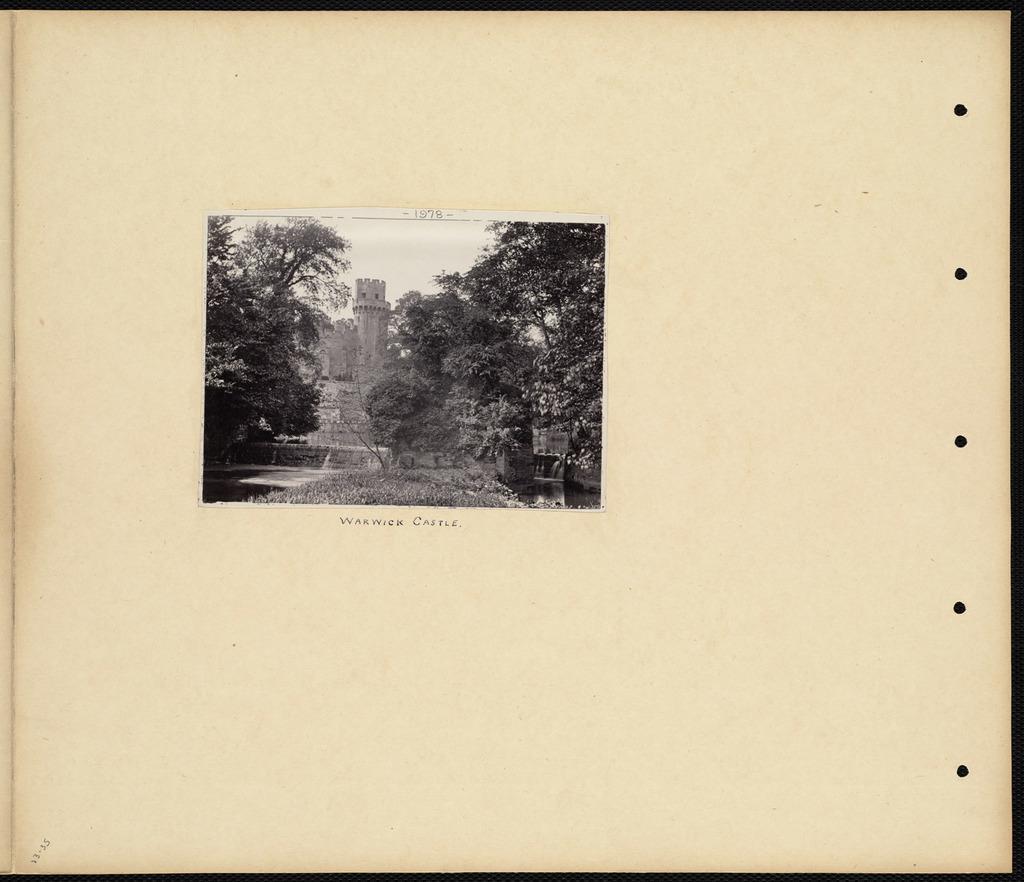How would you summarize this image in a sentence or two? In the image we can see a paper. In the paper we can see some trees and fort. 